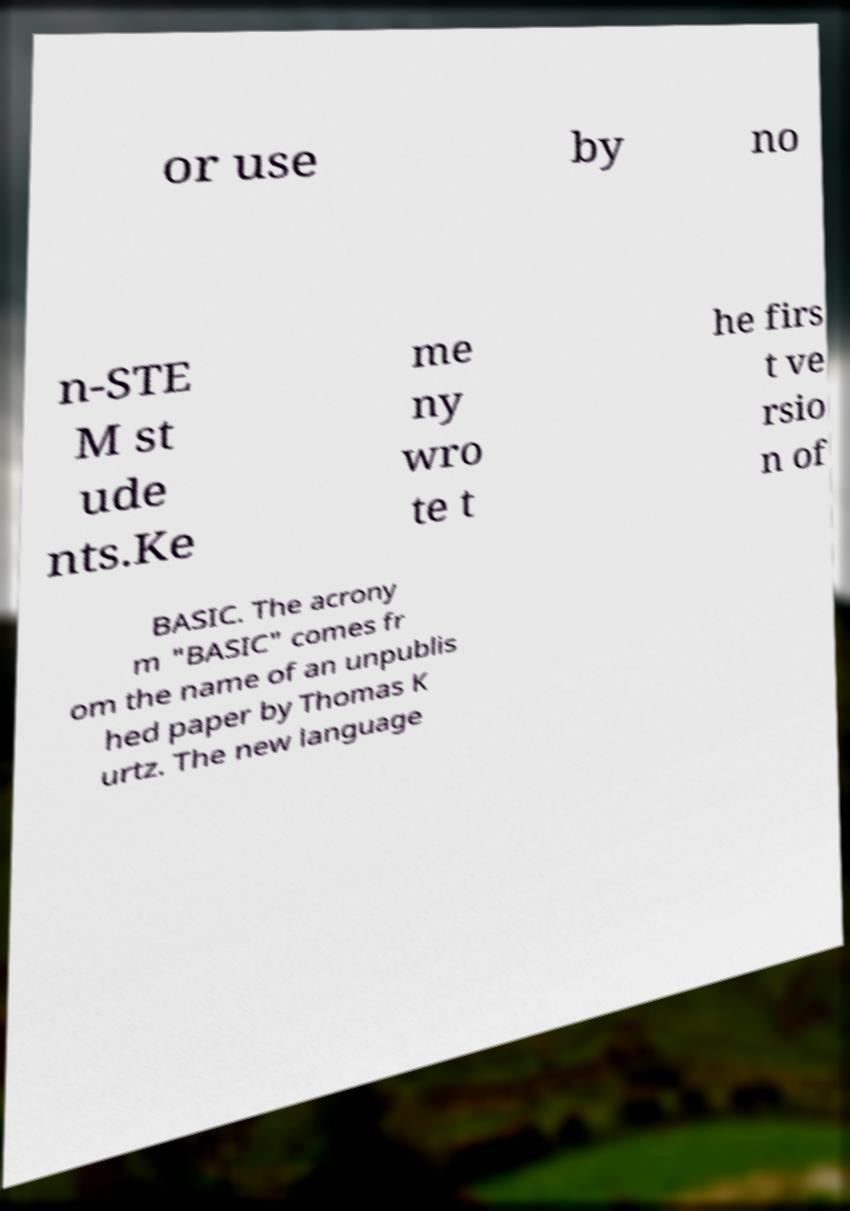Can you read and provide the text displayed in the image?This photo seems to have some interesting text. Can you extract and type it out for me? or use by no n-STE M st ude nts.Ke me ny wro te t he firs t ve rsio n of BASIC. The acrony m "BASIC" comes fr om the name of an unpublis hed paper by Thomas K urtz. The new language 